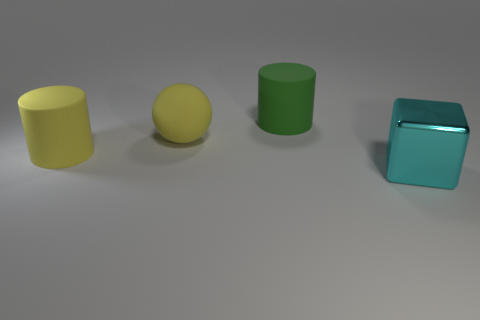What color is the other big rubber object that is the same shape as the large green thing?
Ensure brevity in your answer.  Yellow. What is the size of the object that is in front of the ball and to the left of the cyan shiny thing?
Give a very brief answer. Large. There is a big cylinder that is right of the cylinder left of the big green matte thing; what number of cylinders are on the left side of it?
Offer a terse response. 1. How many large objects are either blue matte things or yellow matte balls?
Make the answer very short. 1. Is the cylinder that is to the right of the big yellow ball made of the same material as the large sphere?
Your answer should be very brief. Yes. There is a large cylinder left of the cylinder that is behind the large cylinder in front of the big yellow sphere; what is its material?
Offer a terse response. Rubber. Is there anything else that is the same size as the green rubber cylinder?
Keep it short and to the point. Yes. How many matte things are large green things or big objects?
Provide a succinct answer. 3. Are any yellow matte cylinders visible?
Your answer should be compact. Yes. There is a rubber cylinder on the right side of the rubber cylinder that is in front of the big green object; what color is it?
Make the answer very short. Green. 